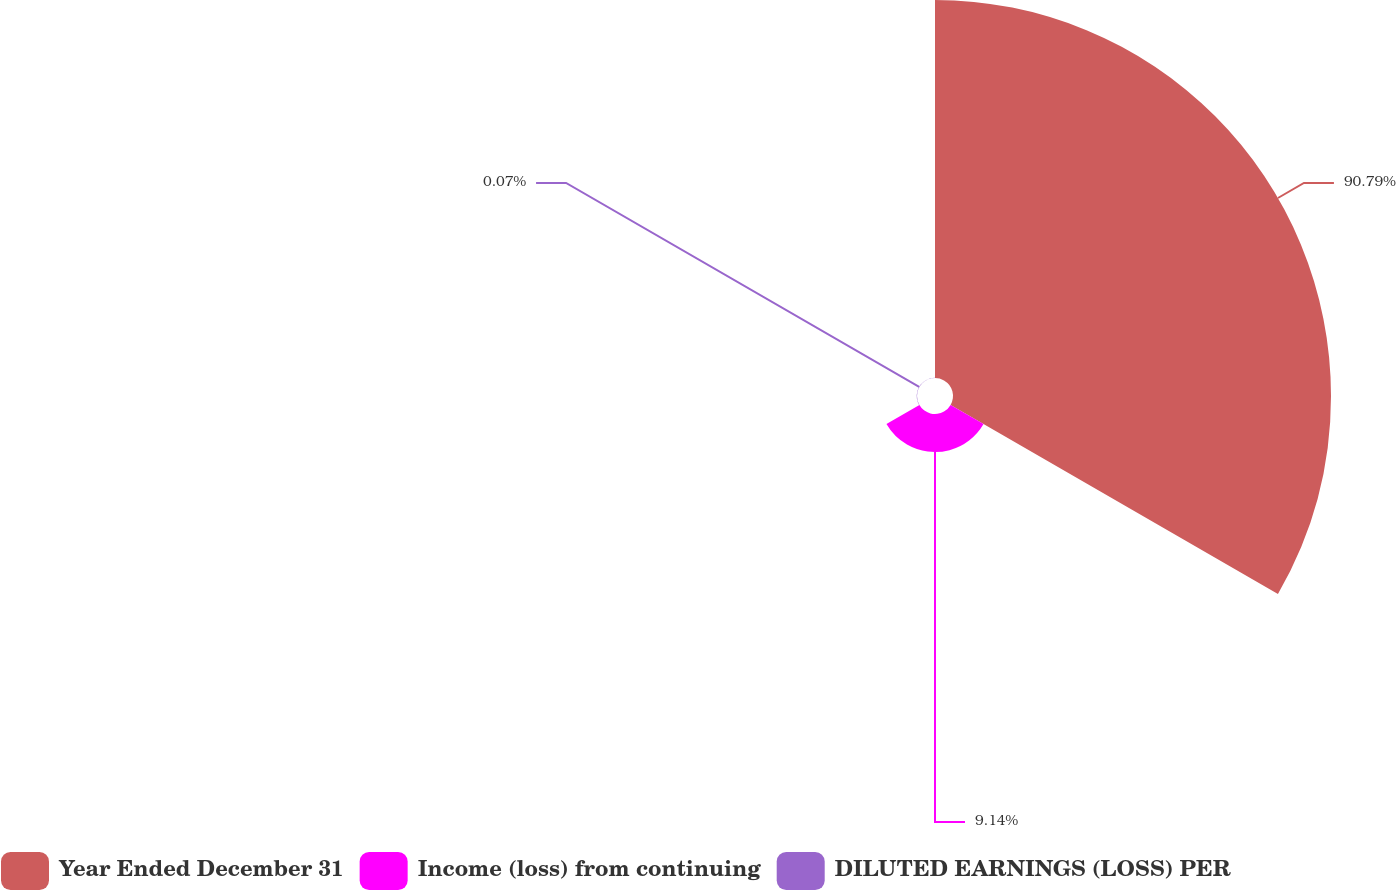Convert chart. <chart><loc_0><loc_0><loc_500><loc_500><pie_chart><fcel>Year Ended December 31<fcel>Income (loss) from continuing<fcel>DILUTED EARNINGS (LOSS) PER<nl><fcel>90.79%<fcel>9.14%<fcel>0.07%<nl></chart> 